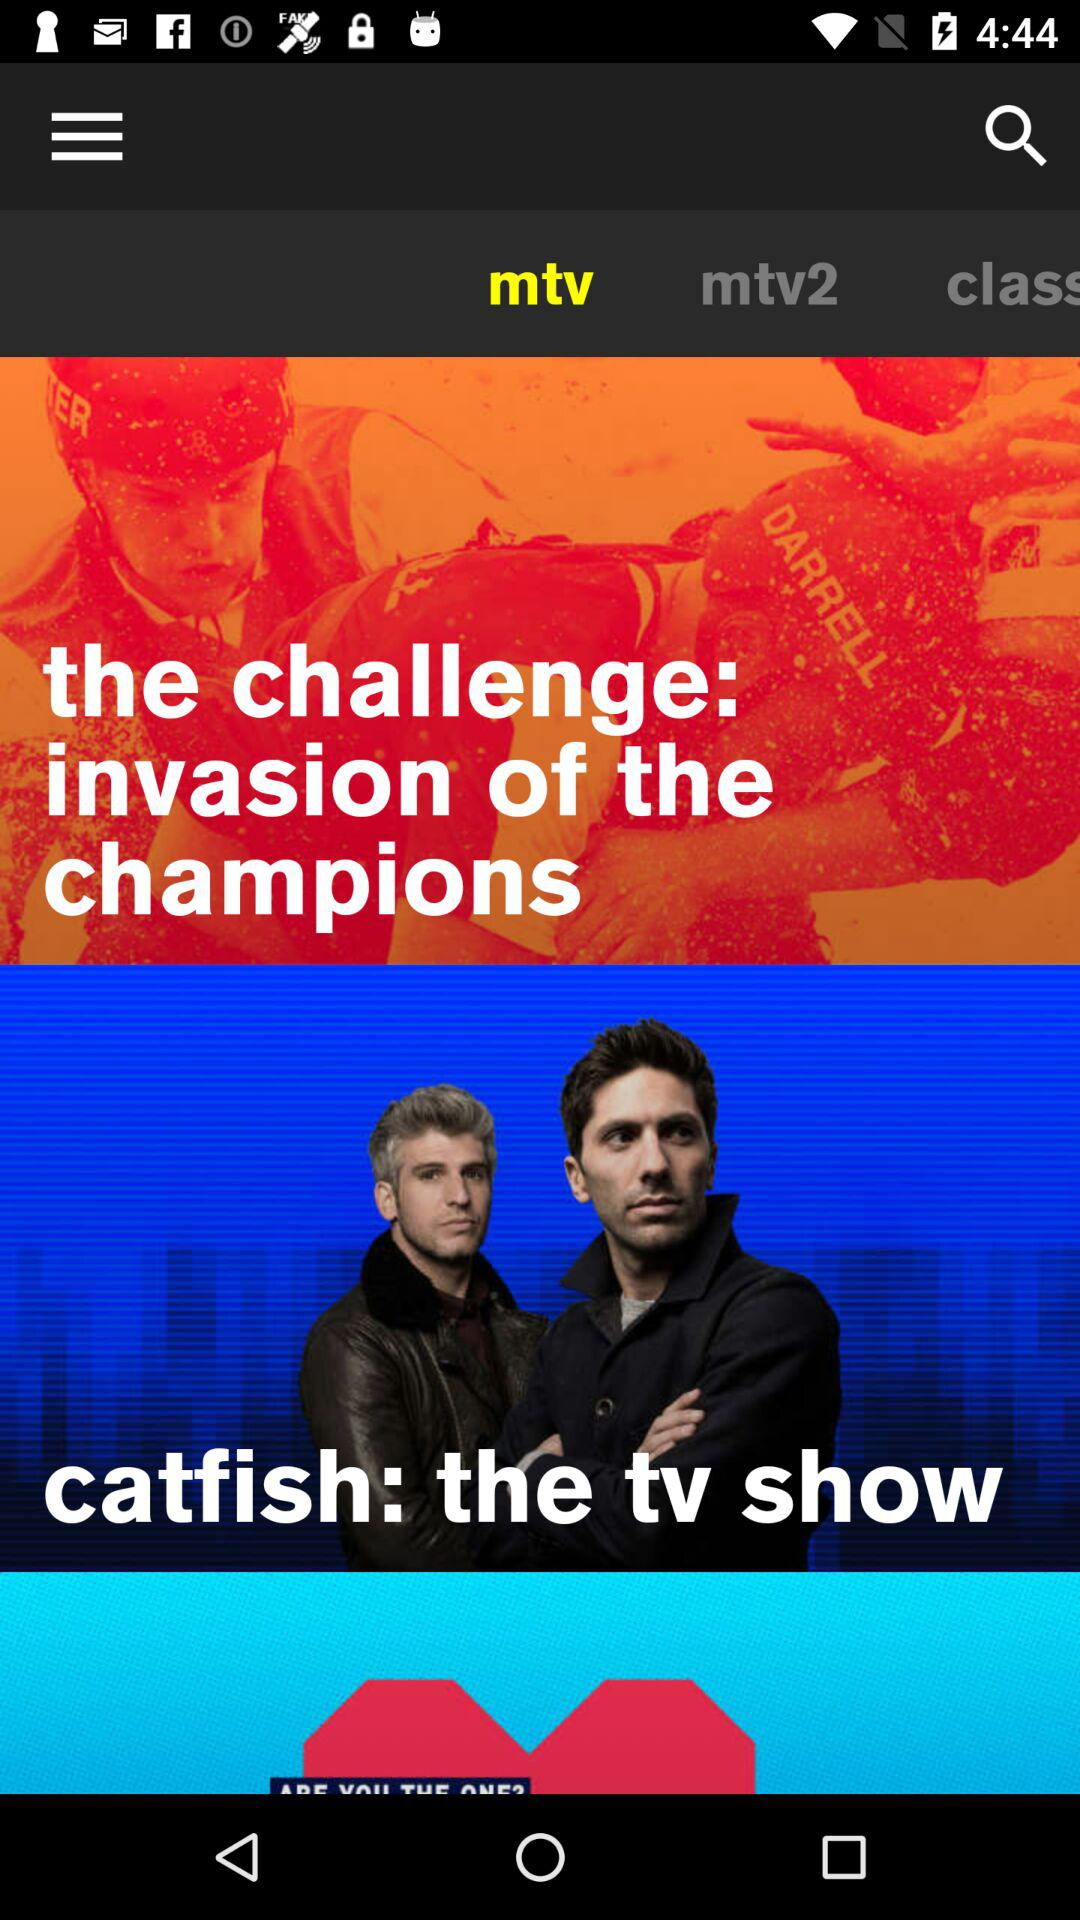Which tab is selected? The selected tab is "mtv". 